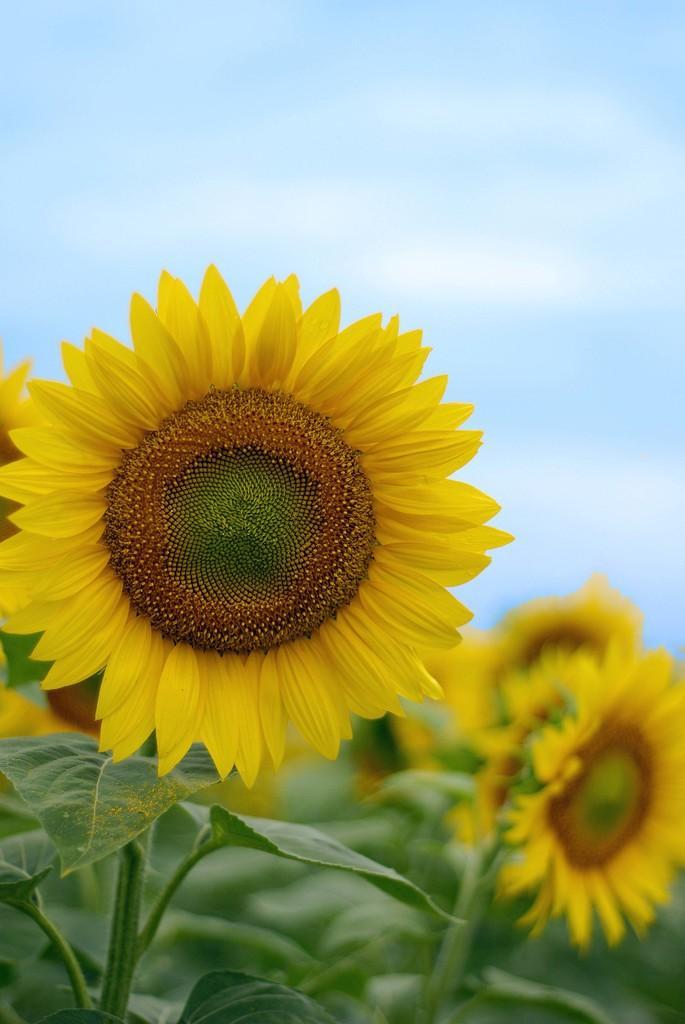Describe this image in one or two sentences. In this picture there are sunflowers in the center of the image and there is sky at the top side of the image. 